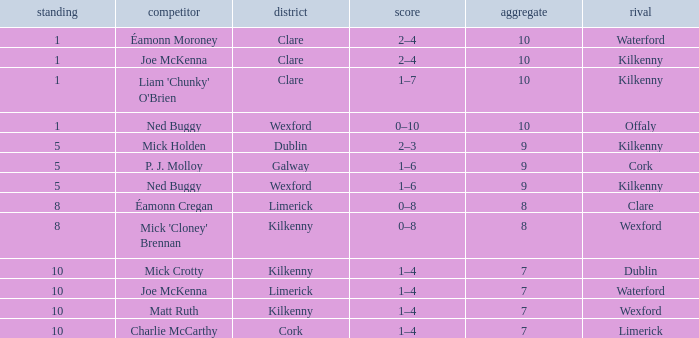Could you help me parse every detail presented in this table? {'header': ['standing', 'competitor', 'district', 'score', 'aggregate', 'rival'], 'rows': [['1', 'Éamonn Moroney', 'Clare', '2–4', '10', 'Waterford'], ['1', 'Joe McKenna', 'Clare', '2–4', '10', 'Kilkenny'], ['1', "Liam 'Chunky' O'Brien", 'Clare', '1–7', '10', 'Kilkenny'], ['1', 'Ned Buggy', 'Wexford', '0–10', '10', 'Offaly'], ['5', 'Mick Holden', 'Dublin', '2–3', '9', 'Kilkenny'], ['5', 'P. J. Molloy', 'Galway', '1–6', '9', 'Cork'], ['5', 'Ned Buggy', 'Wexford', '1–6', '9', 'Kilkenny'], ['8', 'Éamonn Cregan', 'Limerick', '0–8', '8', 'Clare'], ['8', "Mick 'Cloney' Brennan", 'Kilkenny', '0–8', '8', 'Wexford'], ['10', 'Mick Crotty', 'Kilkenny', '1–4', '7', 'Dublin'], ['10', 'Joe McKenna', 'Limerick', '1–4', '7', 'Waterford'], ['10', 'Matt Ruth', 'Kilkenny', '1–4', '7', 'Wexford'], ['10', 'Charlie McCarthy', 'Cork', '1–4', '7', 'Limerick']]} Which County has a Rank larger than 8, and a Player of joe mckenna? Limerick. 